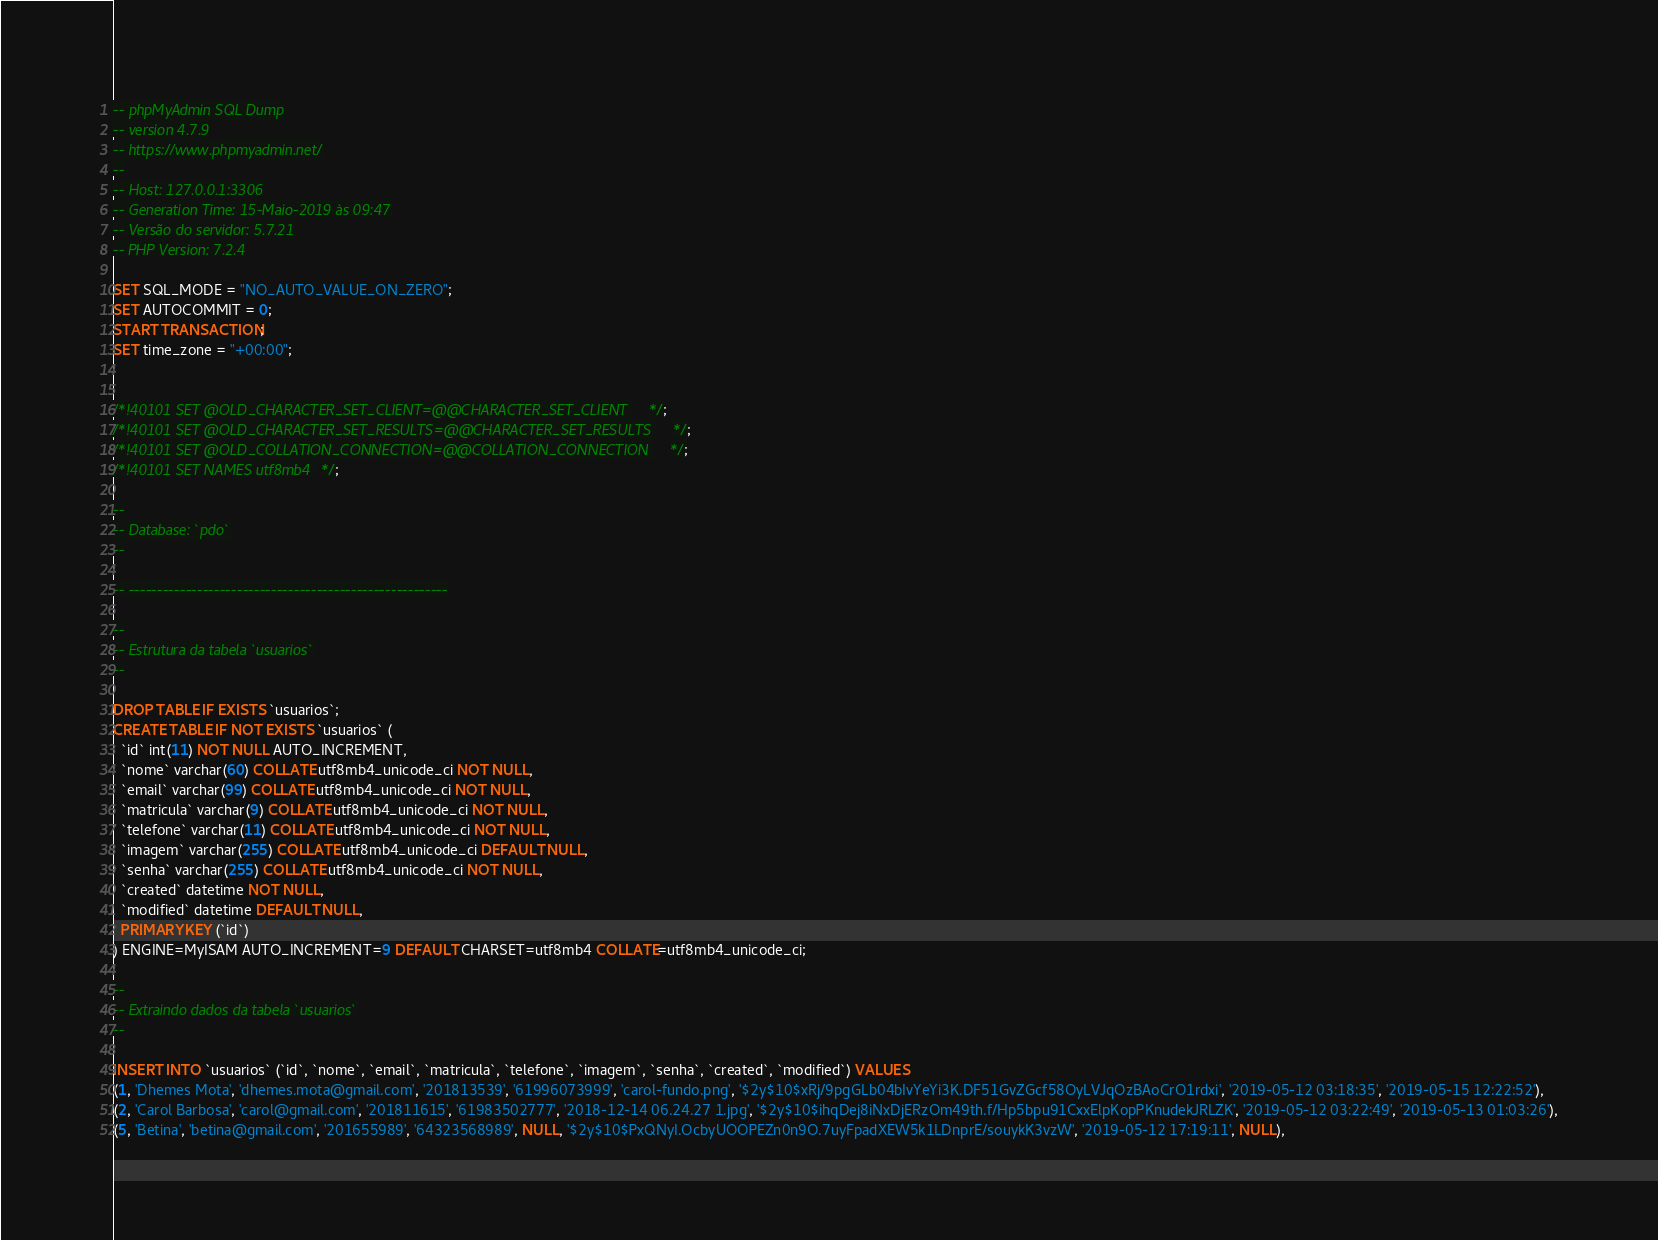<code> <loc_0><loc_0><loc_500><loc_500><_SQL_>-- phpMyAdmin SQL Dump
-- version 4.7.9
-- https://www.phpmyadmin.net/
--
-- Host: 127.0.0.1:3306
-- Generation Time: 15-Maio-2019 às 09:47
-- Versão do servidor: 5.7.21
-- PHP Version: 7.2.4

SET SQL_MODE = "NO_AUTO_VALUE_ON_ZERO";
SET AUTOCOMMIT = 0;
START TRANSACTION;
SET time_zone = "+00:00";


/*!40101 SET @OLD_CHARACTER_SET_CLIENT=@@CHARACTER_SET_CLIENT */;
/*!40101 SET @OLD_CHARACTER_SET_RESULTS=@@CHARACTER_SET_RESULTS */;
/*!40101 SET @OLD_COLLATION_CONNECTION=@@COLLATION_CONNECTION */;
/*!40101 SET NAMES utf8mb4 */;

--
-- Database: `pdo`
--

-- --------------------------------------------------------

--
-- Estrutura da tabela `usuarios`
--

DROP TABLE IF EXISTS `usuarios`;
CREATE TABLE IF NOT EXISTS `usuarios` (
  `id` int(11) NOT NULL AUTO_INCREMENT,
  `nome` varchar(60) COLLATE utf8mb4_unicode_ci NOT NULL,
  `email` varchar(99) COLLATE utf8mb4_unicode_ci NOT NULL,
  `matricula` varchar(9) COLLATE utf8mb4_unicode_ci NOT NULL,
  `telefone` varchar(11) COLLATE utf8mb4_unicode_ci NOT NULL,
  `imagem` varchar(255) COLLATE utf8mb4_unicode_ci DEFAULT NULL,
  `senha` varchar(255) COLLATE utf8mb4_unicode_ci NOT NULL,
  `created` datetime NOT NULL,
  `modified` datetime DEFAULT NULL,
  PRIMARY KEY (`id`)
) ENGINE=MyISAM AUTO_INCREMENT=9 DEFAULT CHARSET=utf8mb4 COLLATE=utf8mb4_unicode_ci;

--
-- Extraindo dados da tabela `usuarios`
--

INSERT INTO `usuarios` (`id`, `nome`, `email`, `matricula`, `telefone`, `imagem`, `senha`, `created`, `modified`) VALUES
(1, 'Dhemes Mota', 'dhemes.mota@gmail.com', '201813539', '61996073999', 'carol-fundo.png', '$2y$10$xRj/9pgGLb04bIvYeYi3K.DF51GvZGcf58OyLVJqOzBAoCrO1rdxi', '2019-05-12 03:18:35', '2019-05-15 12:22:52'),
(2, 'Carol Barbosa', 'carol@gmail.com', '201811615', '61983502777', '2018-12-14 06.24.27 1.jpg', '$2y$10$ihqDej8iNxDjERzOm49th.f/Hp5bpu91CxxElpKopPKnudekJRLZK', '2019-05-12 03:22:49', '2019-05-13 01:03:26'),
(5, 'Betina', 'betina@gmail.com', '201655989', '64323568989', NULL, '$2y$10$PxQNyI.OcbyUOOPEZn0n9O.7uyFpadXEW5k1LDnprE/souykK3vzW', '2019-05-12 17:19:11', NULL),</code> 